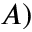Convert formula to latex. <formula><loc_0><loc_0><loc_500><loc_500>A )</formula> 